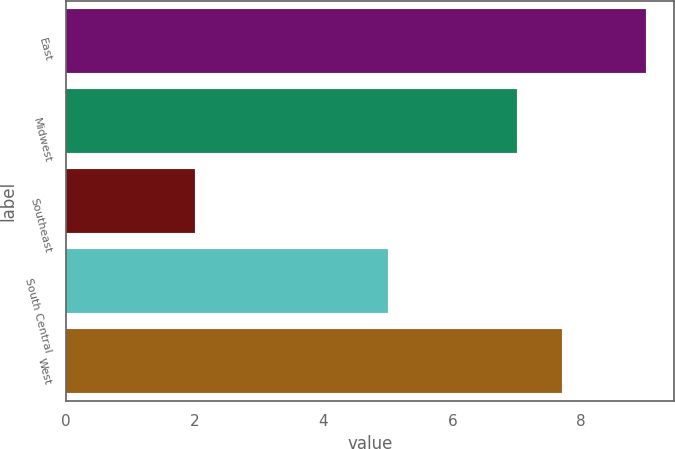Convert chart to OTSL. <chart><loc_0><loc_0><loc_500><loc_500><bar_chart><fcel>East<fcel>Midwest<fcel>Southeast<fcel>South Central<fcel>West<nl><fcel>9<fcel>7<fcel>2<fcel>5<fcel>7.7<nl></chart> 